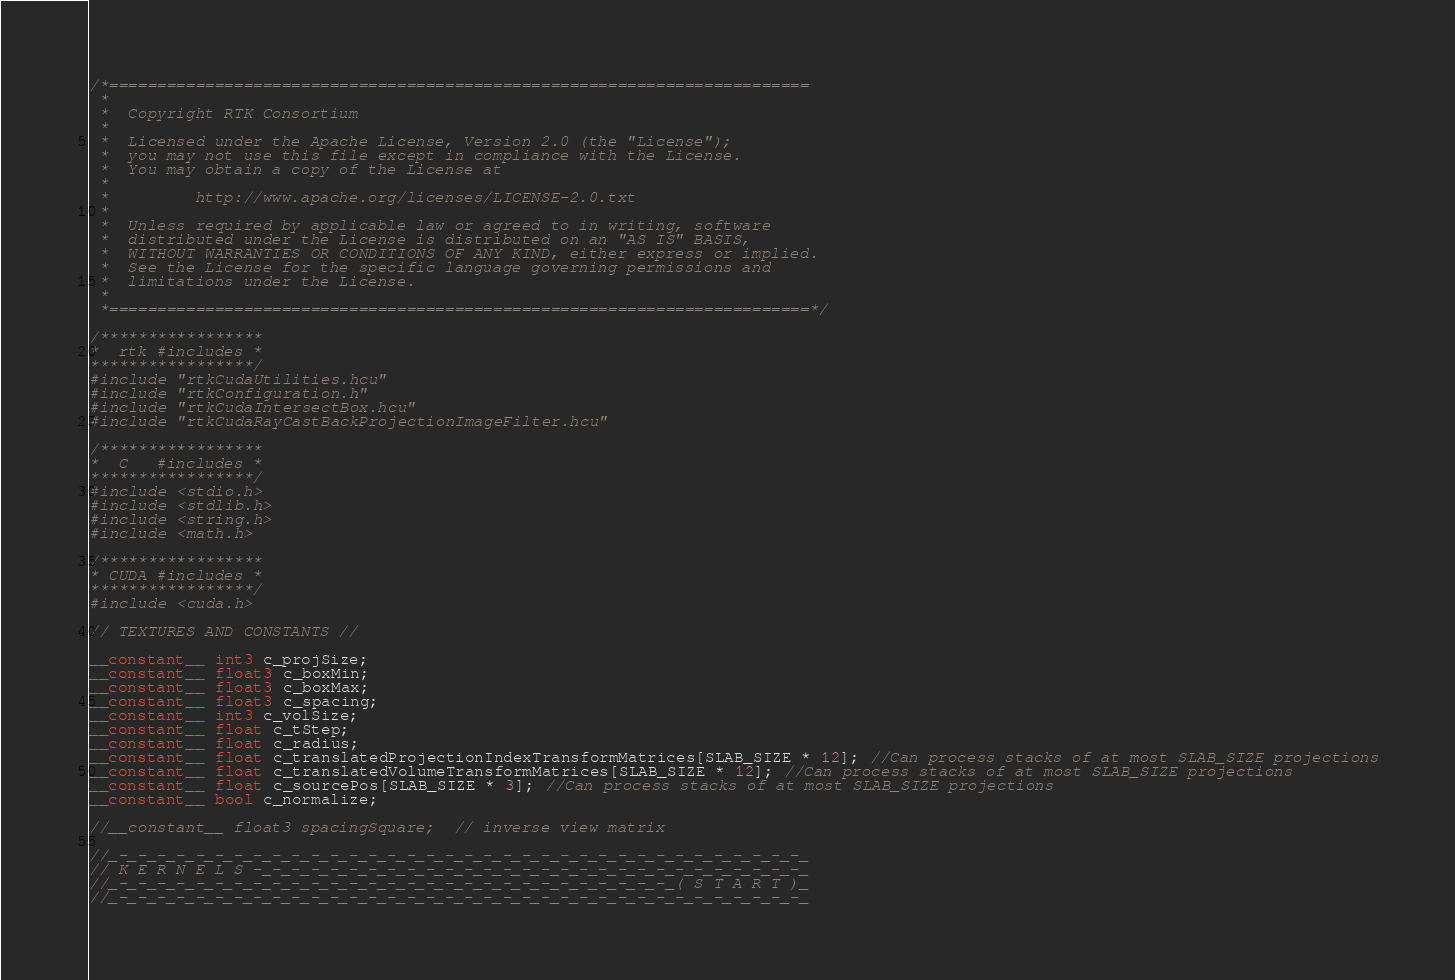Convert code to text. <code><loc_0><loc_0><loc_500><loc_500><_Cuda_>/*=========================================================================
 *
 *  Copyright RTK Consortium
 *
 *  Licensed under the Apache License, Version 2.0 (the "License");
 *  you may not use this file except in compliance with the License.
 *  You may obtain a copy of the License at
 *
 *         http://www.apache.org/licenses/LICENSE-2.0.txt
 *
 *  Unless required by applicable law or agreed to in writing, software
 *  distributed under the License is distributed on an "AS IS" BASIS,
 *  WITHOUT WARRANTIES OR CONDITIONS OF ANY KIND, either express or implied.
 *  See the License for the specific language governing permissions and
 *  limitations under the License.
 *
 *=========================================================================*/

/*****************
*  rtk #includes *
*****************/
#include "rtkCudaUtilities.hcu"
#include "rtkConfiguration.h"
#include "rtkCudaIntersectBox.hcu"
#include "rtkCudaRayCastBackProjectionImageFilter.hcu"

/*****************
*  C   #includes *
*****************/
#include <stdio.h>
#include <stdlib.h>
#include <string.h>
#include <math.h>

/*****************
* CUDA #includes *
*****************/
#include <cuda.h>

// TEXTURES AND CONSTANTS //

__constant__ int3 c_projSize;
__constant__ float3 c_boxMin;
__constant__ float3 c_boxMax;
__constant__ float3 c_spacing;
__constant__ int3 c_volSize;
__constant__ float c_tStep;
__constant__ float c_radius;
__constant__ float c_translatedProjectionIndexTransformMatrices[SLAB_SIZE * 12]; //Can process stacks of at most SLAB_SIZE projections
__constant__ float c_translatedVolumeTransformMatrices[SLAB_SIZE * 12]; //Can process stacks of at most SLAB_SIZE projections
__constant__ float c_sourcePos[SLAB_SIZE * 3]; //Can process stacks of at most SLAB_SIZE projections
__constant__ bool c_normalize;

//__constant__ float3 spacingSquare;  // inverse view matrix

//_-_-_-_-_-_-_-_-_-_-_-_-_-_-_-_-_-_-_-_-_-_-_-_-_-_-_-_-_-_-_-_-_-_-_-_-_
// K E R N E L S -_-_-_-_-_-_-_-_-_-_-_-_-_-_-_-_-_-_-_-_-_-_-_-_-_-_-_-_-_
//_-_-_-_-_-_-_-_-_-_-_-_-_-_-_-_-_-_-_-_-_-_-_-_-_-_-_-_-_-_( S T A R T )_
//_-_-_-_-_-_-_-_-_-_-_-_-_-_-_-_-_-_-_-_-_-_-_-_-_-_-_-_-_-_-_-_-_-_-_-_-_
</code> 